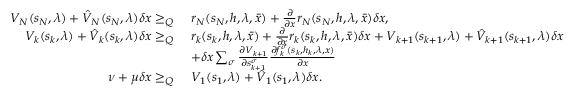Convert formula to latex. <formula><loc_0><loc_0><loc_500><loc_500>\begin{array} { r l } { V _ { N } ( s _ { N } , \lambda ) + \hat { V } _ { N } ( s _ { N } , \lambda ) \delta x \geq _ { Q } } & { \ r _ { N } ( s _ { N } , h , \lambda , \bar { x } ) + \frac { \partial } { \partial x } r _ { N } ( s _ { N } , h , \lambda , \bar { x } ) \delta x , } \\ { V _ { k } ( s _ { k } , \lambda ) + \hat { V } _ { k } ( s _ { k } , \lambda ) \delta x \geq _ { Q } } & { \ r _ { k } ( s _ { k } , h , \lambda , \bar { x } ) + \frac { \partial } { \partial x } r _ { k } ( s _ { k } , h , \lambda , \bar { x } ) \delta x + V _ { k + 1 } ( s _ { k + 1 } , \lambda ) + \hat { V } _ { k + 1 } ( s _ { k + 1 } , \lambda ) \delta x } \\ & { \ + \delta x \sum _ { \sigma } \frac { \partial V _ { k + 1 } } { \partial s _ { k + 1 } ^ { \sigma } } \frac { \partial f _ { k } ^ { \sigma } ( s _ { k } , h _ { k } , \lambda , x ) } { \partial x } } \\ { \nu + \mu \delta x \geq _ { Q } } & { \ V _ { 1 } ( s _ { 1 } , \lambda ) + \hat { V } _ { 1 } ( s _ { 1 } , \lambda ) \delta x . } \end{array}</formula> 